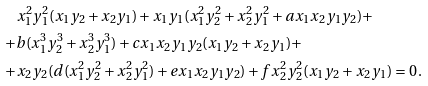<formula> <loc_0><loc_0><loc_500><loc_500>& x _ { 1 } ^ { 2 } y _ { 1 } ^ { 2 } ( x _ { 1 } y _ { 2 } + x _ { 2 } y _ { 1 } ) + x _ { 1 } y _ { 1 } ( x _ { 1 } ^ { 2 } y _ { 2 } ^ { 2 } + x _ { 2 } ^ { 2 } y _ { 1 } ^ { 2 } + a x _ { 1 } x _ { 2 } y _ { 1 } y _ { 2 } ) + \\ + & b ( x _ { 1 } ^ { 3 } y _ { 2 } ^ { 3 } + x _ { 2 } ^ { 3 } y _ { 1 } ^ { 3 } ) + c x _ { 1 } x _ { 2 } y _ { 1 } y _ { 2 } ( x _ { 1 } y _ { 2 } + x _ { 2 } y _ { 1 } ) + \\ + & x _ { 2 } y _ { 2 } ( d ( x _ { 1 } ^ { 2 } y _ { 2 } ^ { 2 } + x _ { 2 } ^ { 2 } y _ { 1 } ^ { 2 } ) + e x _ { 1 } x _ { 2 } y _ { 1 } y _ { 2 } ) + f x _ { 2 } ^ { 2 } y _ { 2 } ^ { 2 } ( x _ { 1 } y _ { 2 } + x _ { 2 } y _ { 1 } ) = 0 \, .</formula> 